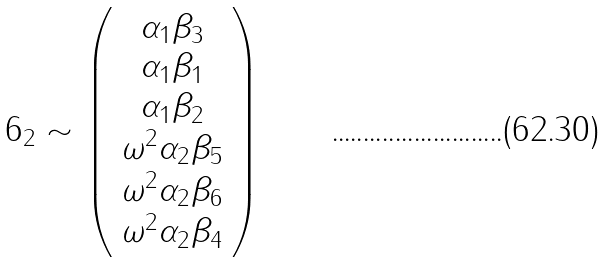Convert formula to latex. <formula><loc_0><loc_0><loc_500><loc_500>6 _ { 2 } \sim \left ( \begin{array} { c } \alpha _ { 1 } \beta _ { 3 } \\ \alpha _ { 1 } \beta _ { 1 } \\ \alpha _ { 1 } \beta _ { 2 } \\ \omega ^ { 2 } \alpha _ { 2 } \beta _ { 5 } \\ \omega ^ { 2 } \alpha _ { 2 } \beta _ { 6 } \\ \omega ^ { 2 } \alpha _ { 2 } \beta _ { 4 } \end{array} \right )</formula> 